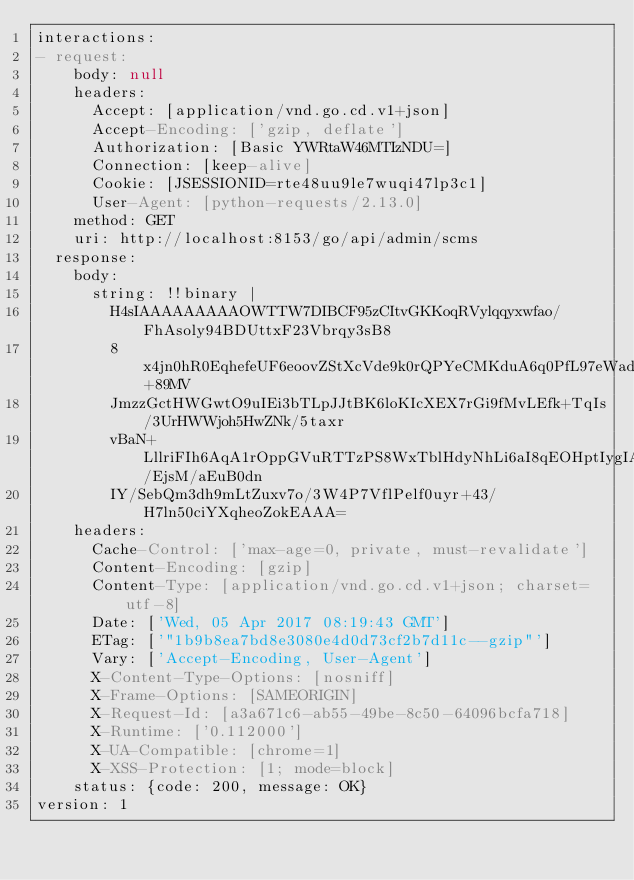Convert code to text. <code><loc_0><loc_0><loc_500><loc_500><_YAML_>interactions:
- request:
    body: null
    headers:
      Accept: [application/vnd.go.cd.v1+json]
      Accept-Encoding: ['gzip, deflate']
      Authorization: [Basic YWRtaW46MTIzNDU=]
      Connection: [keep-alive]
      Cookie: [JSESSIONID=rte48uu9le7wuqi47lp3c1]
      User-Agent: [python-requests/2.13.0]
    method: GET
    uri: http://localhost:8153/go/api/admin/scms
  response:
    body:
      string: !!binary |
        H4sIAAAAAAAAAOWTTW7DIBCF95zCItvGKKoqRVylqqyxwfao/FhAsoly94BDUttxF23Vbrqy3sB8
        8x4jn0hR0EqhefeUF6eoovZStXcVde9k0rQPYeCMKduA6q0PfL97eWadZTAgA6HRMN9oT8e+89MV
        JmzzGctHWGwtO9uIEi3bTLpJJtBK6loKIcXEX7rGi9fMvLEfk+TqIs/3UrHWWjoh5HwZNk/5taxr
        vBaN+LllriFIh6AqA1rOppGVuRTTzPS8WxTblHdyNhLi6aI8qEOHptIygIAAy6e/EjsM/aEuB0dn
        IY/SebQm3dh9mLtZuxv7o/3W4P7VflPelf0uyr+43/H7ln50ciYXqheoZokEAAA=
    headers:
      Cache-Control: ['max-age=0, private, must-revalidate']
      Content-Encoding: [gzip]
      Content-Type: [application/vnd.go.cd.v1+json; charset=utf-8]
      Date: ['Wed, 05 Apr 2017 08:19:43 GMT']
      ETag: ['"1b9b8ea7bd8e3080e4d0d73cf2b7d11c--gzip"']
      Vary: ['Accept-Encoding, User-Agent']
      X-Content-Type-Options: [nosniff]
      X-Frame-Options: [SAMEORIGIN]
      X-Request-Id: [a3a671c6-ab55-49be-8c50-64096bcfa718]
      X-Runtime: ['0.112000']
      X-UA-Compatible: [chrome=1]
      X-XSS-Protection: [1; mode=block]
    status: {code: 200, message: OK}
version: 1
</code> 